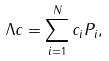Convert formula to latex. <formula><loc_0><loc_0><loc_500><loc_500>\Lambda c = \sum _ { i = 1 } ^ { N } c _ { i } P _ { i } ,</formula> 